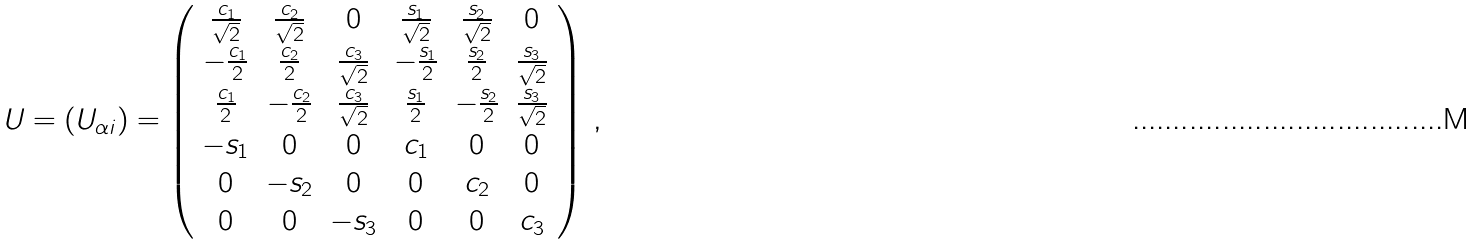<formula> <loc_0><loc_0><loc_500><loc_500>U = \left ( U _ { \alpha i } \right ) = \left ( \begin{array} { c c c c c c } \frac { c _ { 1 } } { \sqrt { 2 } } & \frac { c _ { 2 } } { \sqrt { 2 } } & 0 & \frac { s _ { 1 } } { \sqrt { 2 } } & \frac { s _ { 2 } } { \sqrt { 2 } } & 0 \\ - \frac { c _ { 1 } } { 2 } & \frac { c _ { 2 } } { 2 } & \frac { c _ { 3 } } { \sqrt { 2 } } & - \frac { s _ { 1 } } { 2 } & \frac { s _ { 2 } } { 2 } & \frac { s _ { 3 } } { \sqrt { 2 } } \\ \frac { c _ { 1 } } { 2 } & - \frac { c _ { 2 } } { 2 } & \frac { c _ { 3 } } { \sqrt { 2 } } & \frac { s _ { 1 } } { 2 } & - \frac { s _ { 2 } } { 2 } & \frac { s _ { 3 } } { \sqrt { 2 } } \\ - s _ { 1 } & 0 & 0 & c _ { 1 } & 0 & 0 \\ 0 & - s _ { 2 } & 0 & 0 & c _ { 2 } & 0 \\ 0 & 0 & - s _ { 3 } & 0 & 0 & c _ { 3 } \end{array} \right ) \, ,</formula> 